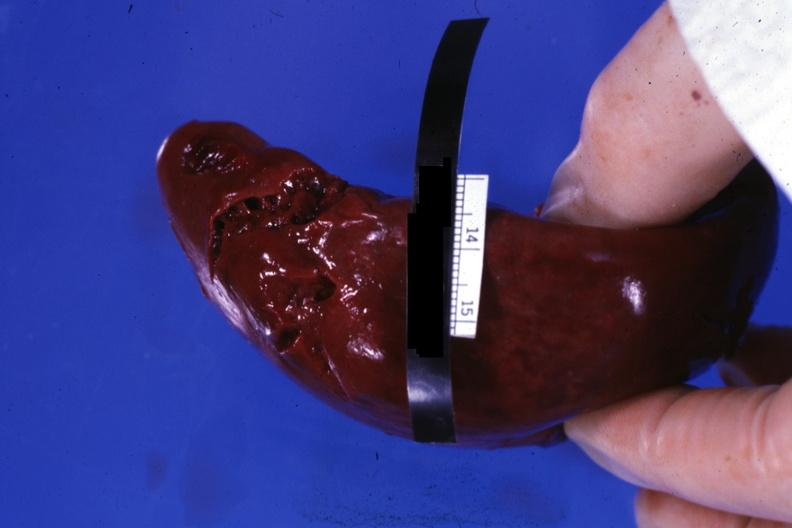what does this image show?
Answer the question using a single word or phrase. External view of lacerations of capsule apparently done during surgical procedure 